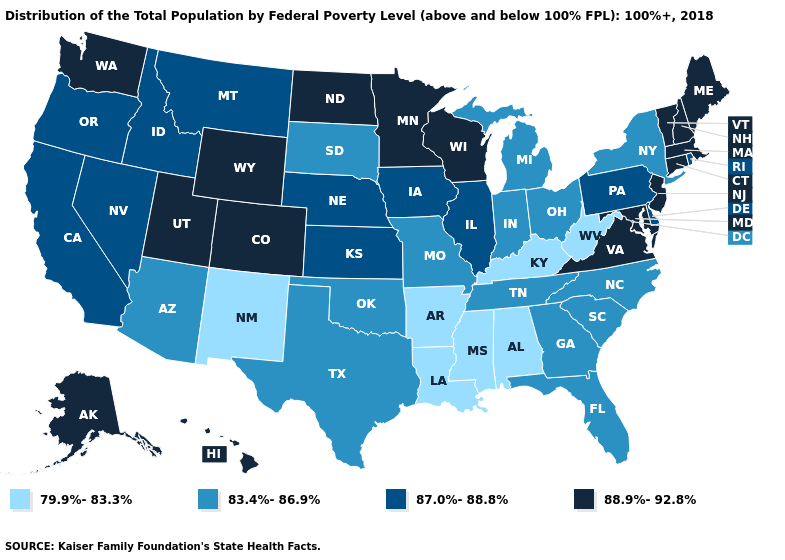Does the first symbol in the legend represent the smallest category?
Keep it brief. Yes. Is the legend a continuous bar?
Write a very short answer. No. Name the states that have a value in the range 88.9%-92.8%?
Write a very short answer. Alaska, Colorado, Connecticut, Hawaii, Maine, Maryland, Massachusetts, Minnesota, New Hampshire, New Jersey, North Dakota, Utah, Vermont, Virginia, Washington, Wisconsin, Wyoming. What is the highest value in the MidWest ?
Short answer required. 88.9%-92.8%. What is the highest value in the MidWest ?
Short answer required. 88.9%-92.8%. What is the value of Kentucky?
Write a very short answer. 79.9%-83.3%. Is the legend a continuous bar?
Answer briefly. No. What is the highest value in the USA?
Concise answer only. 88.9%-92.8%. What is the value of Pennsylvania?
Keep it brief. 87.0%-88.8%. Which states have the lowest value in the USA?
Be succinct. Alabama, Arkansas, Kentucky, Louisiana, Mississippi, New Mexico, West Virginia. Does the map have missing data?
Answer briefly. No. Does West Virginia have the lowest value in the South?
Be succinct. Yes. Which states have the lowest value in the USA?
Short answer required. Alabama, Arkansas, Kentucky, Louisiana, Mississippi, New Mexico, West Virginia. Does the map have missing data?
Write a very short answer. No. Does Illinois have the lowest value in the MidWest?
Write a very short answer. No. 